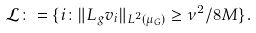<formula> <loc_0><loc_0><loc_500><loc_500>\mathcal { L } \colon = \{ i \colon \| L _ { g } v _ { i } \| _ { L ^ { 2 } ( \mu _ { G } ) } \geq \nu ^ { 2 } / 8 M \} .</formula> 